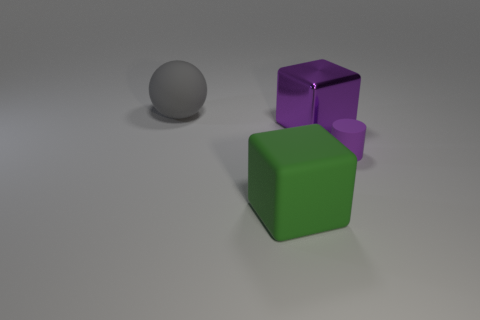Add 4 gray matte balls. How many objects exist? 8 Subtract all matte cubes. Subtract all matte things. How many objects are left? 0 Add 3 large matte cubes. How many large matte cubes are left? 4 Add 4 green metallic balls. How many green metallic balls exist? 4 Subtract 0 red balls. How many objects are left? 4 Subtract all cylinders. How many objects are left? 3 Subtract all green cubes. Subtract all cyan cylinders. How many cubes are left? 1 